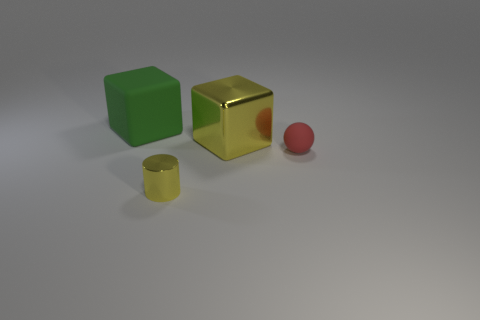There is a big thing to the right of the big green rubber cube; does it have the same color as the object in front of the small red object?
Provide a succinct answer. Yes. What is the shape of the small red rubber object?
Keep it short and to the point. Sphere. How many tiny things are the same color as the big metal object?
Offer a terse response. 1. What material is the tiny thing that is to the left of the metal object behind the small object behind the tiny metallic cylinder made of?
Make the answer very short. Metal. How many purple objects are large things or shiny things?
Keep it short and to the point. 0. There is a rubber thing to the right of the big block that is behind the cube in front of the green cube; what is its size?
Keep it short and to the point. Small. There is a shiny object that is the same shape as the big green rubber object; what size is it?
Provide a succinct answer. Large. What number of big things are yellow metal cubes or green things?
Make the answer very short. 2. Do the thing in front of the small rubber object and the large object on the right side of the shiny cylinder have the same material?
Your answer should be compact. Yes. There is a large object to the right of the large matte thing; what is its material?
Your answer should be compact. Metal. 